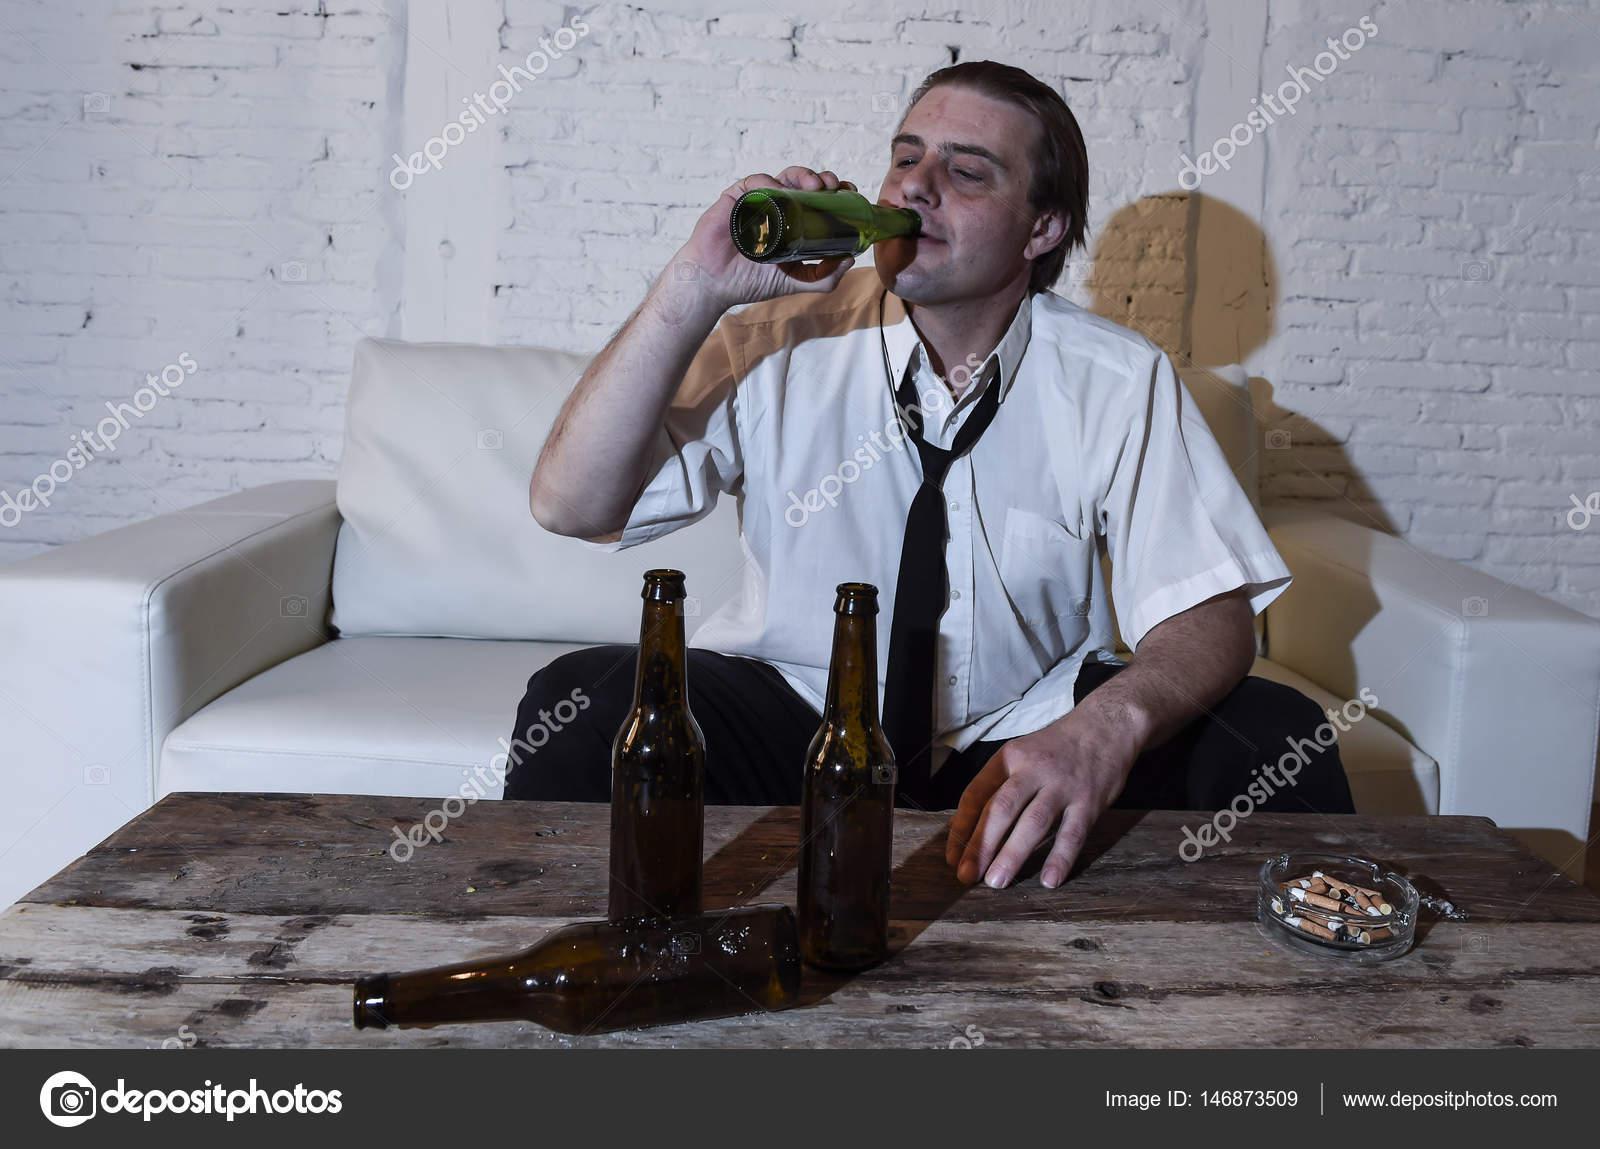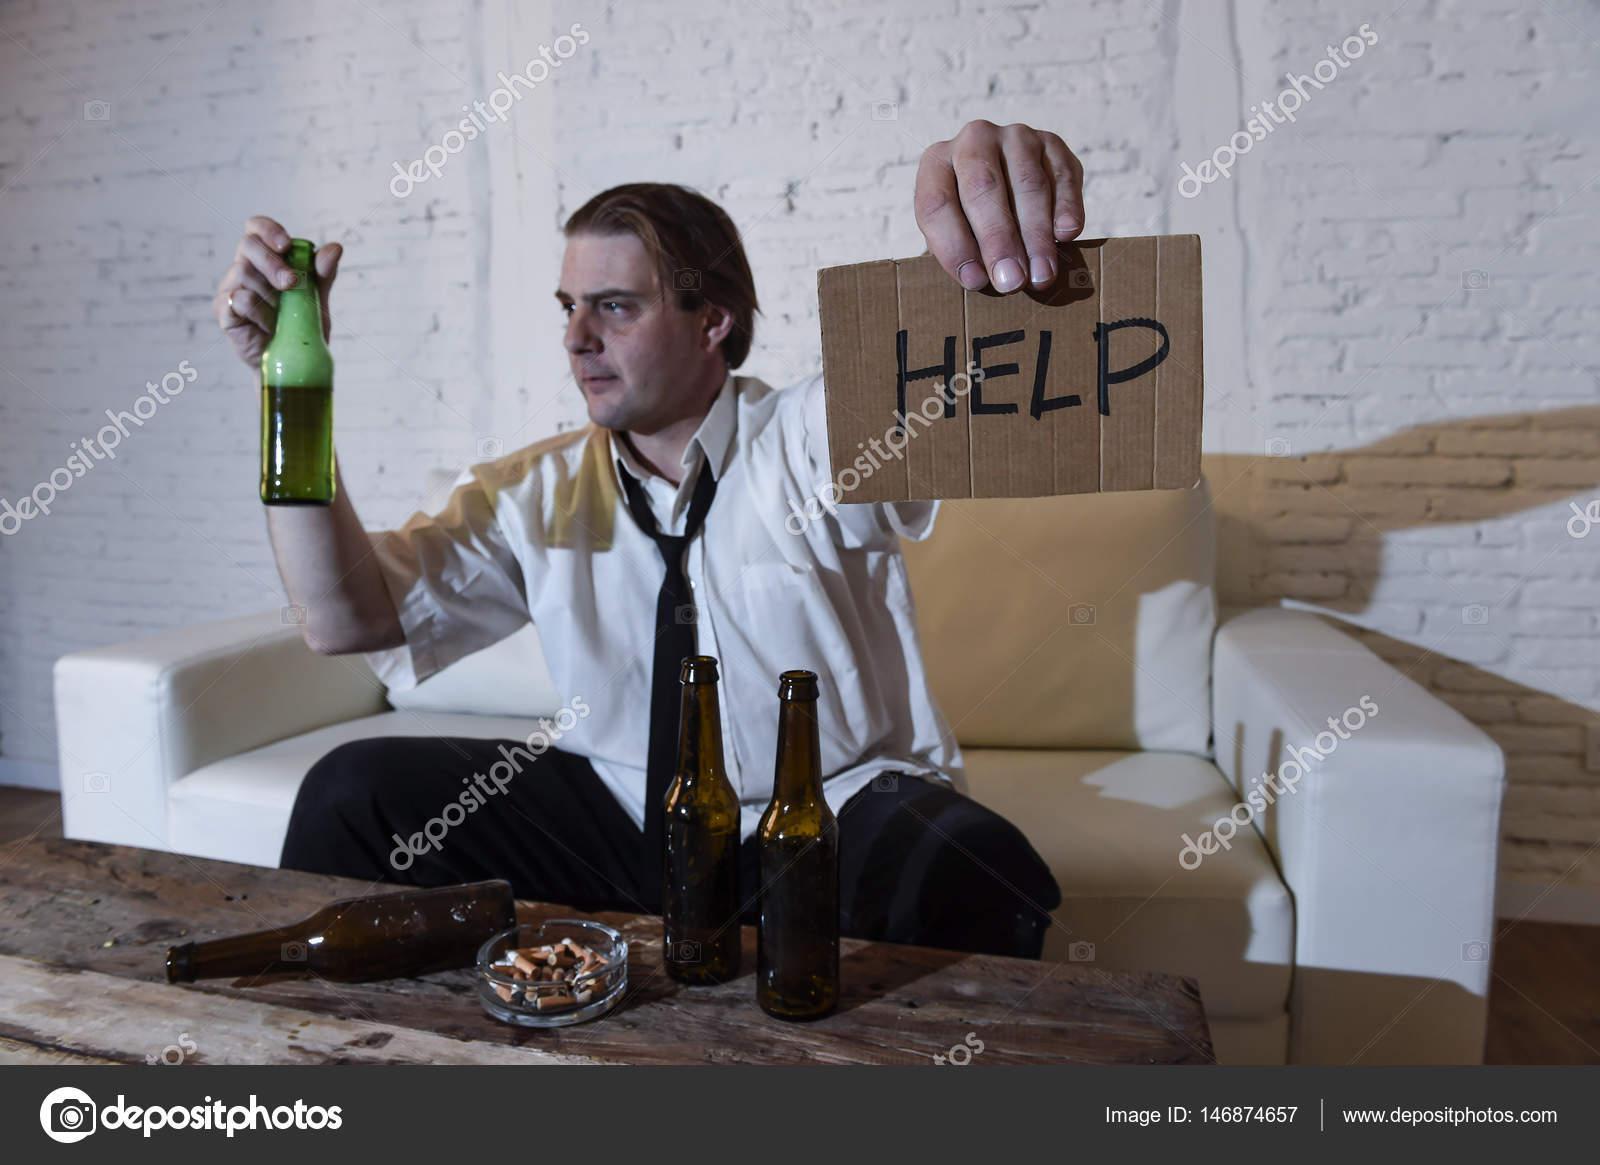The first image is the image on the left, the second image is the image on the right. Examine the images to the left and right. Is the description "The right image shows a man, sitting on a wide white chair behind bottles on a table, wearing a necktie and holding up a cardboard sign." accurate? Answer yes or no. Yes. The first image is the image on the left, the second image is the image on the right. Examine the images to the left and right. Is the description "The left and right image contains the same number of identical men in the same shirts.." accurate? Answer yes or no. Yes. 